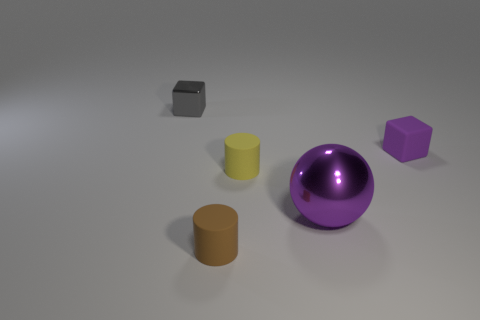Are there any other things that are the same size as the purple ball?
Offer a terse response. No. Is there any other thing that is the same material as the large thing?
Your answer should be very brief. Yes. There is a small rubber object that is behind the tiny yellow rubber cylinder; is it the same shape as the small object that is on the left side of the small brown rubber thing?
Your response must be concise. Yes. Are there fewer tiny gray objects that are right of the shiny sphere than small yellow rubber cylinders?
Provide a succinct answer. Yes. What number of small matte cylinders are the same color as the rubber cube?
Offer a very short reply. 0. How big is the cube that is right of the brown rubber cylinder?
Ensure brevity in your answer.  Small. There is a small thing that is on the left side of the tiny cylinder in front of the rubber cylinder behind the large metal object; what shape is it?
Your response must be concise. Cube. What is the shape of the small rubber object that is behind the tiny brown rubber thing and on the left side of the tiny purple cube?
Ensure brevity in your answer.  Cylinder. Are there any matte blocks of the same size as the brown cylinder?
Your response must be concise. Yes. There is a rubber thing in front of the small yellow matte thing; is its shape the same as the small metal object?
Your answer should be compact. No. 